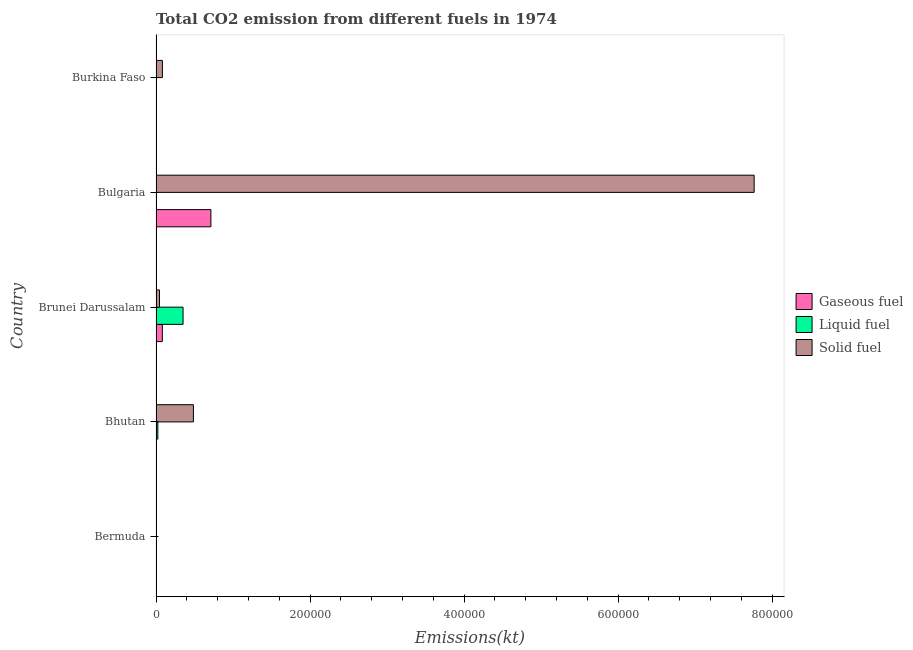What is the label of the 1st group of bars from the top?
Give a very brief answer. Burkina Faso. What is the amount of co2 emissions from liquid fuel in Bermuda?
Make the answer very short. 3.67. Across all countries, what is the maximum amount of co2 emissions from solid fuel?
Your answer should be compact. 7.77e+05. Across all countries, what is the minimum amount of co2 emissions from liquid fuel?
Keep it short and to the point. 3.67. In which country was the amount of co2 emissions from gaseous fuel maximum?
Give a very brief answer. Bulgaria. In which country was the amount of co2 emissions from liquid fuel minimum?
Provide a short and direct response. Bermuda. What is the total amount of co2 emissions from solid fuel in the graph?
Keep it short and to the point. 8.38e+05. What is the difference between the amount of co2 emissions from solid fuel in Bermuda and that in Brunei Darussalam?
Your answer should be compact. -4488.41. What is the difference between the amount of co2 emissions from gaseous fuel in Burkina Faso and the amount of co2 emissions from liquid fuel in Brunei Darussalam?
Offer a very short reply. -3.49e+04. What is the average amount of co2 emissions from liquid fuel per country?
Keep it short and to the point. 7556.22. What is the difference between the amount of co2 emissions from solid fuel and amount of co2 emissions from liquid fuel in Brunei Darussalam?
Your answer should be compact. -3.06e+04. What is the difference between the highest and the second highest amount of co2 emissions from gaseous fuel?
Provide a short and direct response. 6.31e+04. What is the difference between the highest and the lowest amount of co2 emissions from gaseous fuel?
Ensure brevity in your answer.  7.13e+04. What does the 3rd bar from the top in Bhutan represents?
Offer a very short reply. Gaseous fuel. What does the 2nd bar from the bottom in Brunei Darussalam represents?
Ensure brevity in your answer.  Liquid fuel. Is it the case that in every country, the sum of the amount of co2 emissions from gaseous fuel and amount of co2 emissions from liquid fuel is greater than the amount of co2 emissions from solid fuel?
Your response must be concise. No. How many bars are there?
Your response must be concise. 15. How many countries are there in the graph?
Your response must be concise. 5. Are the values on the major ticks of X-axis written in scientific E-notation?
Give a very brief answer. No. Does the graph contain grids?
Keep it short and to the point. No. How many legend labels are there?
Make the answer very short. 3. How are the legend labels stacked?
Keep it short and to the point. Vertical. What is the title of the graph?
Provide a succinct answer. Total CO2 emission from different fuels in 1974. Does "Transport equipments" appear as one of the legend labels in the graph?
Your answer should be very brief. No. What is the label or title of the X-axis?
Give a very brief answer. Emissions(kt). What is the label or title of the Y-axis?
Offer a very short reply. Country. What is the Emissions(kt) of Gaseous fuel in Bermuda?
Make the answer very short. 443.71. What is the Emissions(kt) in Liquid fuel in Bermuda?
Ensure brevity in your answer.  3.67. What is the Emissions(kt) of Solid fuel in Bermuda?
Keep it short and to the point. 3.67. What is the Emissions(kt) of Gaseous fuel in Bhutan?
Ensure brevity in your answer.  3.67. What is the Emissions(kt) of Liquid fuel in Bhutan?
Offer a terse response. 2368.88. What is the Emissions(kt) of Solid fuel in Bhutan?
Offer a terse response. 4.85e+04. What is the Emissions(kt) in Gaseous fuel in Brunei Darussalam?
Your answer should be very brief. 8184.74. What is the Emissions(kt) in Liquid fuel in Brunei Darussalam?
Your response must be concise. 3.51e+04. What is the Emissions(kt) in Solid fuel in Brunei Darussalam?
Offer a very short reply. 4492.07. What is the Emissions(kt) in Gaseous fuel in Bulgaria?
Your answer should be very brief. 7.13e+04. What is the Emissions(kt) of Liquid fuel in Bulgaria?
Provide a short and direct response. 205.35. What is the Emissions(kt) in Solid fuel in Bulgaria?
Provide a succinct answer. 7.77e+05. What is the Emissions(kt) of Gaseous fuel in Burkina Faso?
Ensure brevity in your answer.  205.35. What is the Emissions(kt) in Liquid fuel in Burkina Faso?
Your response must be concise. 88.01. What is the Emissions(kt) of Solid fuel in Burkina Faso?
Offer a very short reply. 8316.76. Across all countries, what is the maximum Emissions(kt) in Gaseous fuel?
Your answer should be very brief. 7.13e+04. Across all countries, what is the maximum Emissions(kt) of Liquid fuel?
Make the answer very short. 3.51e+04. Across all countries, what is the maximum Emissions(kt) of Solid fuel?
Offer a terse response. 7.77e+05. Across all countries, what is the minimum Emissions(kt) in Gaseous fuel?
Offer a terse response. 3.67. Across all countries, what is the minimum Emissions(kt) in Liquid fuel?
Offer a terse response. 3.67. Across all countries, what is the minimum Emissions(kt) in Solid fuel?
Offer a very short reply. 3.67. What is the total Emissions(kt) of Gaseous fuel in the graph?
Offer a terse response. 8.01e+04. What is the total Emissions(kt) in Liquid fuel in the graph?
Keep it short and to the point. 3.78e+04. What is the total Emissions(kt) of Solid fuel in the graph?
Your answer should be compact. 8.38e+05. What is the difference between the Emissions(kt) in Gaseous fuel in Bermuda and that in Bhutan?
Offer a very short reply. 440.04. What is the difference between the Emissions(kt) of Liquid fuel in Bermuda and that in Bhutan?
Ensure brevity in your answer.  -2365.22. What is the difference between the Emissions(kt) in Solid fuel in Bermuda and that in Bhutan?
Ensure brevity in your answer.  -4.85e+04. What is the difference between the Emissions(kt) of Gaseous fuel in Bermuda and that in Brunei Darussalam?
Offer a terse response. -7741.04. What is the difference between the Emissions(kt) of Liquid fuel in Bermuda and that in Brunei Darussalam?
Provide a short and direct response. -3.51e+04. What is the difference between the Emissions(kt) of Solid fuel in Bermuda and that in Brunei Darussalam?
Offer a very short reply. -4488.41. What is the difference between the Emissions(kt) in Gaseous fuel in Bermuda and that in Bulgaria?
Provide a succinct answer. -7.08e+04. What is the difference between the Emissions(kt) of Liquid fuel in Bermuda and that in Bulgaria?
Provide a succinct answer. -201.69. What is the difference between the Emissions(kt) of Solid fuel in Bermuda and that in Bulgaria?
Give a very brief answer. -7.77e+05. What is the difference between the Emissions(kt) in Gaseous fuel in Bermuda and that in Burkina Faso?
Give a very brief answer. 238.35. What is the difference between the Emissions(kt) in Liquid fuel in Bermuda and that in Burkina Faso?
Make the answer very short. -84.34. What is the difference between the Emissions(kt) of Solid fuel in Bermuda and that in Burkina Faso?
Your answer should be very brief. -8313.09. What is the difference between the Emissions(kt) in Gaseous fuel in Bhutan and that in Brunei Darussalam?
Keep it short and to the point. -8181.08. What is the difference between the Emissions(kt) of Liquid fuel in Bhutan and that in Brunei Darussalam?
Your response must be concise. -3.27e+04. What is the difference between the Emissions(kt) in Solid fuel in Bhutan and that in Brunei Darussalam?
Your answer should be very brief. 4.41e+04. What is the difference between the Emissions(kt) in Gaseous fuel in Bhutan and that in Bulgaria?
Your response must be concise. -7.13e+04. What is the difference between the Emissions(kt) in Liquid fuel in Bhutan and that in Bulgaria?
Provide a short and direct response. 2163.53. What is the difference between the Emissions(kt) of Solid fuel in Bhutan and that in Bulgaria?
Your response must be concise. -7.28e+05. What is the difference between the Emissions(kt) of Gaseous fuel in Bhutan and that in Burkina Faso?
Keep it short and to the point. -201.69. What is the difference between the Emissions(kt) of Liquid fuel in Bhutan and that in Burkina Faso?
Offer a very short reply. 2280.87. What is the difference between the Emissions(kt) in Solid fuel in Bhutan and that in Burkina Faso?
Your answer should be very brief. 4.02e+04. What is the difference between the Emissions(kt) of Gaseous fuel in Brunei Darussalam and that in Bulgaria?
Offer a very short reply. -6.31e+04. What is the difference between the Emissions(kt) of Liquid fuel in Brunei Darussalam and that in Bulgaria?
Offer a very short reply. 3.49e+04. What is the difference between the Emissions(kt) of Solid fuel in Brunei Darussalam and that in Bulgaria?
Provide a short and direct response. -7.72e+05. What is the difference between the Emissions(kt) in Gaseous fuel in Brunei Darussalam and that in Burkina Faso?
Keep it short and to the point. 7979.39. What is the difference between the Emissions(kt) of Liquid fuel in Brunei Darussalam and that in Burkina Faso?
Offer a very short reply. 3.50e+04. What is the difference between the Emissions(kt) in Solid fuel in Brunei Darussalam and that in Burkina Faso?
Offer a terse response. -3824.68. What is the difference between the Emissions(kt) in Gaseous fuel in Bulgaria and that in Burkina Faso?
Give a very brief answer. 7.11e+04. What is the difference between the Emissions(kt) in Liquid fuel in Bulgaria and that in Burkina Faso?
Offer a very short reply. 117.34. What is the difference between the Emissions(kt) of Solid fuel in Bulgaria and that in Burkina Faso?
Your answer should be compact. 7.68e+05. What is the difference between the Emissions(kt) in Gaseous fuel in Bermuda and the Emissions(kt) in Liquid fuel in Bhutan?
Ensure brevity in your answer.  -1925.17. What is the difference between the Emissions(kt) of Gaseous fuel in Bermuda and the Emissions(kt) of Solid fuel in Bhutan?
Give a very brief answer. -4.81e+04. What is the difference between the Emissions(kt) in Liquid fuel in Bermuda and the Emissions(kt) in Solid fuel in Bhutan?
Offer a very short reply. -4.85e+04. What is the difference between the Emissions(kt) of Gaseous fuel in Bermuda and the Emissions(kt) of Liquid fuel in Brunei Darussalam?
Keep it short and to the point. -3.47e+04. What is the difference between the Emissions(kt) of Gaseous fuel in Bermuda and the Emissions(kt) of Solid fuel in Brunei Darussalam?
Ensure brevity in your answer.  -4048.37. What is the difference between the Emissions(kt) in Liquid fuel in Bermuda and the Emissions(kt) in Solid fuel in Brunei Darussalam?
Ensure brevity in your answer.  -4488.41. What is the difference between the Emissions(kt) in Gaseous fuel in Bermuda and the Emissions(kt) in Liquid fuel in Bulgaria?
Offer a terse response. 238.35. What is the difference between the Emissions(kt) in Gaseous fuel in Bermuda and the Emissions(kt) in Solid fuel in Bulgaria?
Ensure brevity in your answer.  -7.76e+05. What is the difference between the Emissions(kt) in Liquid fuel in Bermuda and the Emissions(kt) in Solid fuel in Bulgaria?
Provide a succinct answer. -7.77e+05. What is the difference between the Emissions(kt) in Gaseous fuel in Bermuda and the Emissions(kt) in Liquid fuel in Burkina Faso?
Your answer should be compact. 355.7. What is the difference between the Emissions(kt) of Gaseous fuel in Bermuda and the Emissions(kt) of Solid fuel in Burkina Faso?
Ensure brevity in your answer.  -7873.05. What is the difference between the Emissions(kt) of Liquid fuel in Bermuda and the Emissions(kt) of Solid fuel in Burkina Faso?
Your answer should be compact. -8313.09. What is the difference between the Emissions(kt) of Gaseous fuel in Bhutan and the Emissions(kt) of Liquid fuel in Brunei Darussalam?
Keep it short and to the point. -3.51e+04. What is the difference between the Emissions(kt) in Gaseous fuel in Bhutan and the Emissions(kt) in Solid fuel in Brunei Darussalam?
Make the answer very short. -4488.41. What is the difference between the Emissions(kt) in Liquid fuel in Bhutan and the Emissions(kt) in Solid fuel in Brunei Darussalam?
Give a very brief answer. -2123.19. What is the difference between the Emissions(kt) of Gaseous fuel in Bhutan and the Emissions(kt) of Liquid fuel in Bulgaria?
Make the answer very short. -201.69. What is the difference between the Emissions(kt) of Gaseous fuel in Bhutan and the Emissions(kt) of Solid fuel in Bulgaria?
Offer a very short reply. -7.77e+05. What is the difference between the Emissions(kt) of Liquid fuel in Bhutan and the Emissions(kt) of Solid fuel in Bulgaria?
Provide a succinct answer. -7.74e+05. What is the difference between the Emissions(kt) in Gaseous fuel in Bhutan and the Emissions(kt) in Liquid fuel in Burkina Faso?
Offer a very short reply. -84.34. What is the difference between the Emissions(kt) of Gaseous fuel in Bhutan and the Emissions(kt) of Solid fuel in Burkina Faso?
Offer a very short reply. -8313.09. What is the difference between the Emissions(kt) of Liquid fuel in Bhutan and the Emissions(kt) of Solid fuel in Burkina Faso?
Offer a very short reply. -5947.87. What is the difference between the Emissions(kt) in Gaseous fuel in Brunei Darussalam and the Emissions(kt) in Liquid fuel in Bulgaria?
Ensure brevity in your answer.  7979.39. What is the difference between the Emissions(kt) of Gaseous fuel in Brunei Darussalam and the Emissions(kt) of Solid fuel in Bulgaria?
Your response must be concise. -7.69e+05. What is the difference between the Emissions(kt) of Liquid fuel in Brunei Darussalam and the Emissions(kt) of Solid fuel in Bulgaria?
Your response must be concise. -7.42e+05. What is the difference between the Emissions(kt) in Gaseous fuel in Brunei Darussalam and the Emissions(kt) in Liquid fuel in Burkina Faso?
Provide a short and direct response. 8096.74. What is the difference between the Emissions(kt) of Gaseous fuel in Brunei Darussalam and the Emissions(kt) of Solid fuel in Burkina Faso?
Keep it short and to the point. -132.01. What is the difference between the Emissions(kt) of Liquid fuel in Brunei Darussalam and the Emissions(kt) of Solid fuel in Burkina Faso?
Your answer should be very brief. 2.68e+04. What is the difference between the Emissions(kt) of Gaseous fuel in Bulgaria and the Emissions(kt) of Liquid fuel in Burkina Faso?
Provide a short and direct response. 7.12e+04. What is the difference between the Emissions(kt) in Gaseous fuel in Bulgaria and the Emissions(kt) in Solid fuel in Burkina Faso?
Give a very brief answer. 6.29e+04. What is the difference between the Emissions(kt) of Liquid fuel in Bulgaria and the Emissions(kt) of Solid fuel in Burkina Faso?
Offer a terse response. -8111.4. What is the average Emissions(kt) in Gaseous fuel per country?
Offer a terse response. 1.60e+04. What is the average Emissions(kt) in Liquid fuel per country?
Keep it short and to the point. 7556.22. What is the average Emissions(kt) of Solid fuel per country?
Offer a very short reply. 1.68e+05. What is the difference between the Emissions(kt) of Gaseous fuel and Emissions(kt) of Liquid fuel in Bermuda?
Your answer should be compact. 440.04. What is the difference between the Emissions(kt) in Gaseous fuel and Emissions(kt) in Solid fuel in Bermuda?
Ensure brevity in your answer.  440.04. What is the difference between the Emissions(kt) of Gaseous fuel and Emissions(kt) of Liquid fuel in Bhutan?
Offer a very short reply. -2365.22. What is the difference between the Emissions(kt) of Gaseous fuel and Emissions(kt) of Solid fuel in Bhutan?
Offer a terse response. -4.85e+04. What is the difference between the Emissions(kt) of Liquid fuel and Emissions(kt) of Solid fuel in Bhutan?
Make the answer very short. -4.62e+04. What is the difference between the Emissions(kt) in Gaseous fuel and Emissions(kt) in Liquid fuel in Brunei Darussalam?
Your answer should be very brief. -2.69e+04. What is the difference between the Emissions(kt) of Gaseous fuel and Emissions(kt) of Solid fuel in Brunei Darussalam?
Your response must be concise. 3692.67. What is the difference between the Emissions(kt) of Liquid fuel and Emissions(kt) of Solid fuel in Brunei Darussalam?
Offer a terse response. 3.06e+04. What is the difference between the Emissions(kt) of Gaseous fuel and Emissions(kt) of Liquid fuel in Bulgaria?
Provide a short and direct response. 7.11e+04. What is the difference between the Emissions(kt) of Gaseous fuel and Emissions(kt) of Solid fuel in Bulgaria?
Offer a very short reply. -7.05e+05. What is the difference between the Emissions(kt) of Liquid fuel and Emissions(kt) of Solid fuel in Bulgaria?
Give a very brief answer. -7.77e+05. What is the difference between the Emissions(kt) of Gaseous fuel and Emissions(kt) of Liquid fuel in Burkina Faso?
Your response must be concise. 117.34. What is the difference between the Emissions(kt) of Gaseous fuel and Emissions(kt) of Solid fuel in Burkina Faso?
Offer a very short reply. -8111.4. What is the difference between the Emissions(kt) of Liquid fuel and Emissions(kt) of Solid fuel in Burkina Faso?
Ensure brevity in your answer.  -8228.75. What is the ratio of the Emissions(kt) of Gaseous fuel in Bermuda to that in Bhutan?
Give a very brief answer. 121. What is the ratio of the Emissions(kt) in Liquid fuel in Bermuda to that in Bhutan?
Your response must be concise. 0. What is the ratio of the Emissions(kt) in Gaseous fuel in Bermuda to that in Brunei Darussalam?
Ensure brevity in your answer.  0.05. What is the ratio of the Emissions(kt) of Liquid fuel in Bermuda to that in Brunei Darussalam?
Provide a short and direct response. 0. What is the ratio of the Emissions(kt) in Solid fuel in Bermuda to that in Brunei Darussalam?
Your answer should be compact. 0. What is the ratio of the Emissions(kt) of Gaseous fuel in Bermuda to that in Bulgaria?
Keep it short and to the point. 0.01. What is the ratio of the Emissions(kt) in Liquid fuel in Bermuda to that in Bulgaria?
Your response must be concise. 0.02. What is the ratio of the Emissions(kt) in Gaseous fuel in Bermuda to that in Burkina Faso?
Provide a succinct answer. 2.16. What is the ratio of the Emissions(kt) in Liquid fuel in Bermuda to that in Burkina Faso?
Make the answer very short. 0.04. What is the ratio of the Emissions(kt) of Gaseous fuel in Bhutan to that in Brunei Darussalam?
Provide a succinct answer. 0. What is the ratio of the Emissions(kt) in Liquid fuel in Bhutan to that in Brunei Darussalam?
Your answer should be very brief. 0.07. What is the ratio of the Emissions(kt) of Solid fuel in Bhutan to that in Brunei Darussalam?
Give a very brief answer. 10.81. What is the ratio of the Emissions(kt) in Gaseous fuel in Bhutan to that in Bulgaria?
Make the answer very short. 0. What is the ratio of the Emissions(kt) in Liquid fuel in Bhutan to that in Bulgaria?
Provide a short and direct response. 11.54. What is the ratio of the Emissions(kt) of Solid fuel in Bhutan to that in Bulgaria?
Give a very brief answer. 0.06. What is the ratio of the Emissions(kt) in Gaseous fuel in Bhutan to that in Burkina Faso?
Give a very brief answer. 0.02. What is the ratio of the Emissions(kt) of Liquid fuel in Bhutan to that in Burkina Faso?
Keep it short and to the point. 26.92. What is the ratio of the Emissions(kt) of Solid fuel in Bhutan to that in Burkina Faso?
Provide a short and direct response. 5.84. What is the ratio of the Emissions(kt) in Gaseous fuel in Brunei Darussalam to that in Bulgaria?
Give a very brief answer. 0.11. What is the ratio of the Emissions(kt) of Liquid fuel in Brunei Darussalam to that in Bulgaria?
Your answer should be very brief. 171. What is the ratio of the Emissions(kt) in Solid fuel in Brunei Darussalam to that in Bulgaria?
Your response must be concise. 0.01. What is the ratio of the Emissions(kt) in Gaseous fuel in Brunei Darussalam to that in Burkina Faso?
Your response must be concise. 39.86. What is the ratio of the Emissions(kt) in Liquid fuel in Brunei Darussalam to that in Burkina Faso?
Keep it short and to the point. 399. What is the ratio of the Emissions(kt) in Solid fuel in Brunei Darussalam to that in Burkina Faso?
Your answer should be compact. 0.54. What is the ratio of the Emissions(kt) in Gaseous fuel in Bulgaria to that in Burkina Faso?
Your answer should be very brief. 347.02. What is the ratio of the Emissions(kt) of Liquid fuel in Bulgaria to that in Burkina Faso?
Your answer should be compact. 2.33. What is the ratio of the Emissions(kt) in Solid fuel in Bulgaria to that in Burkina Faso?
Provide a short and direct response. 93.39. What is the difference between the highest and the second highest Emissions(kt) of Gaseous fuel?
Give a very brief answer. 6.31e+04. What is the difference between the highest and the second highest Emissions(kt) in Liquid fuel?
Make the answer very short. 3.27e+04. What is the difference between the highest and the second highest Emissions(kt) of Solid fuel?
Make the answer very short. 7.28e+05. What is the difference between the highest and the lowest Emissions(kt) in Gaseous fuel?
Give a very brief answer. 7.13e+04. What is the difference between the highest and the lowest Emissions(kt) in Liquid fuel?
Give a very brief answer. 3.51e+04. What is the difference between the highest and the lowest Emissions(kt) in Solid fuel?
Your answer should be very brief. 7.77e+05. 